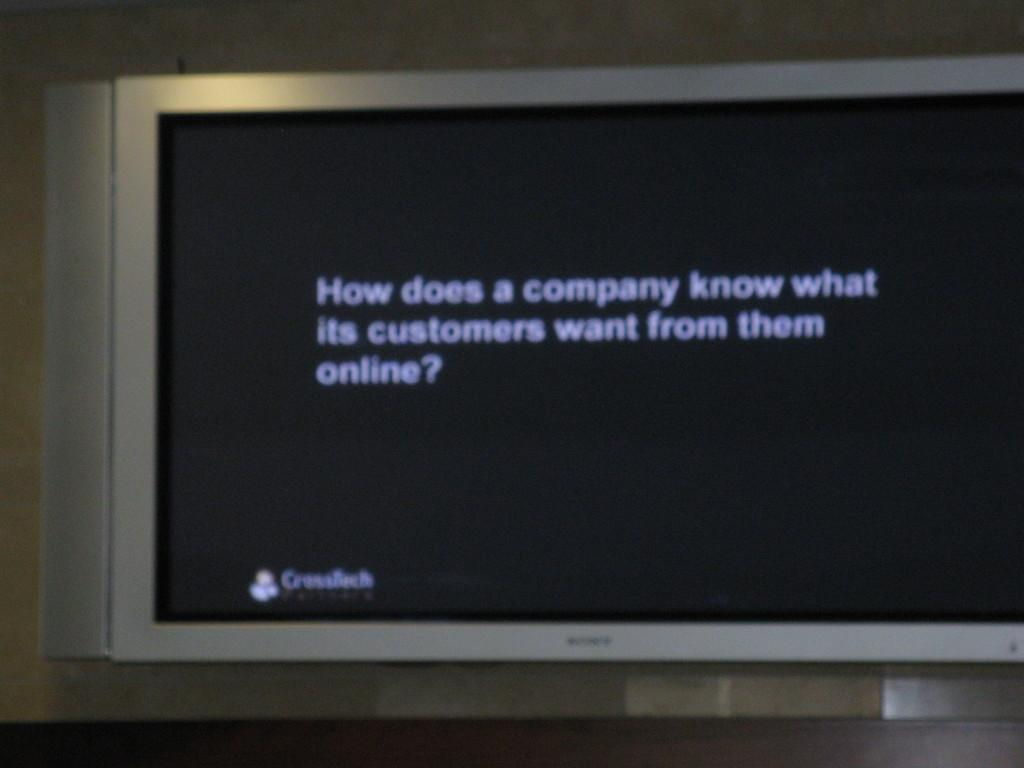<image>
Create a compact narrative representing the image presented. A large tv that says how does a company know what its customers want. 